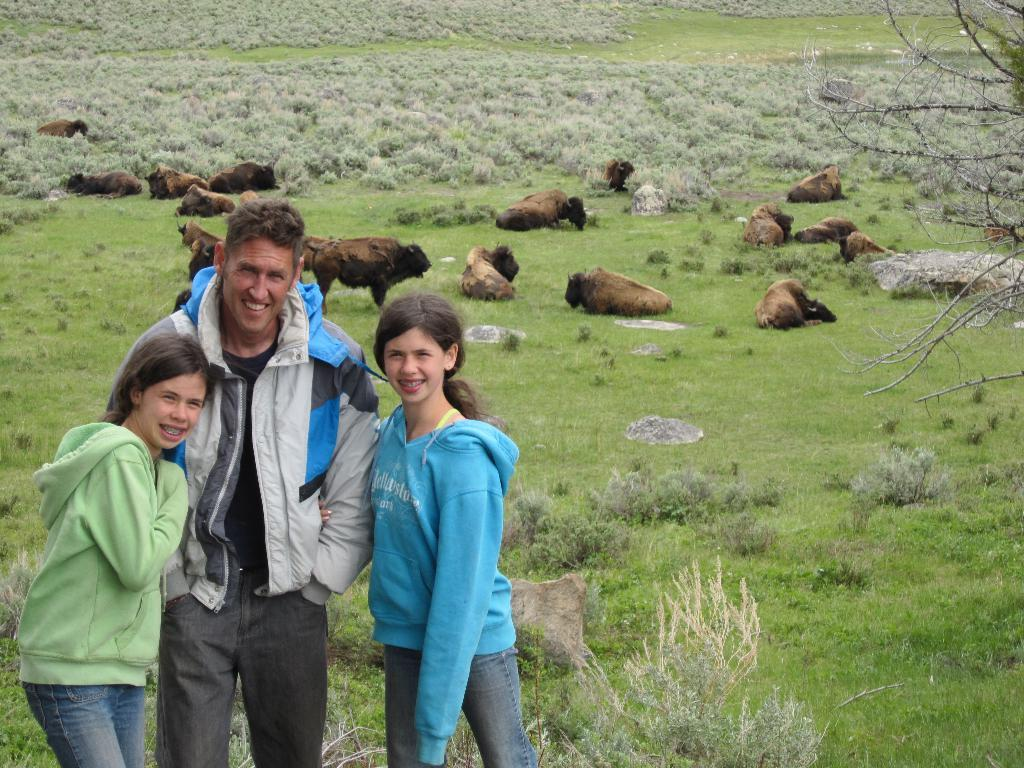What are the people in the image doing? The people in the image are standing and smiling. What type of terrain is visible in the image? There is grass in the image, which suggests a natural setting. What other objects or features can be seen in the image? There is a rock, plants, and branches on the right side of the image. Are there any living creatures in the image? Yes, there are animals in the image. Can you see a watch on the wrist of any person in the image? There is no watch visible on any person's wrist in the image. Is there a bridge connecting the grassy area to another location in the image? There is no bridge present in the image. 